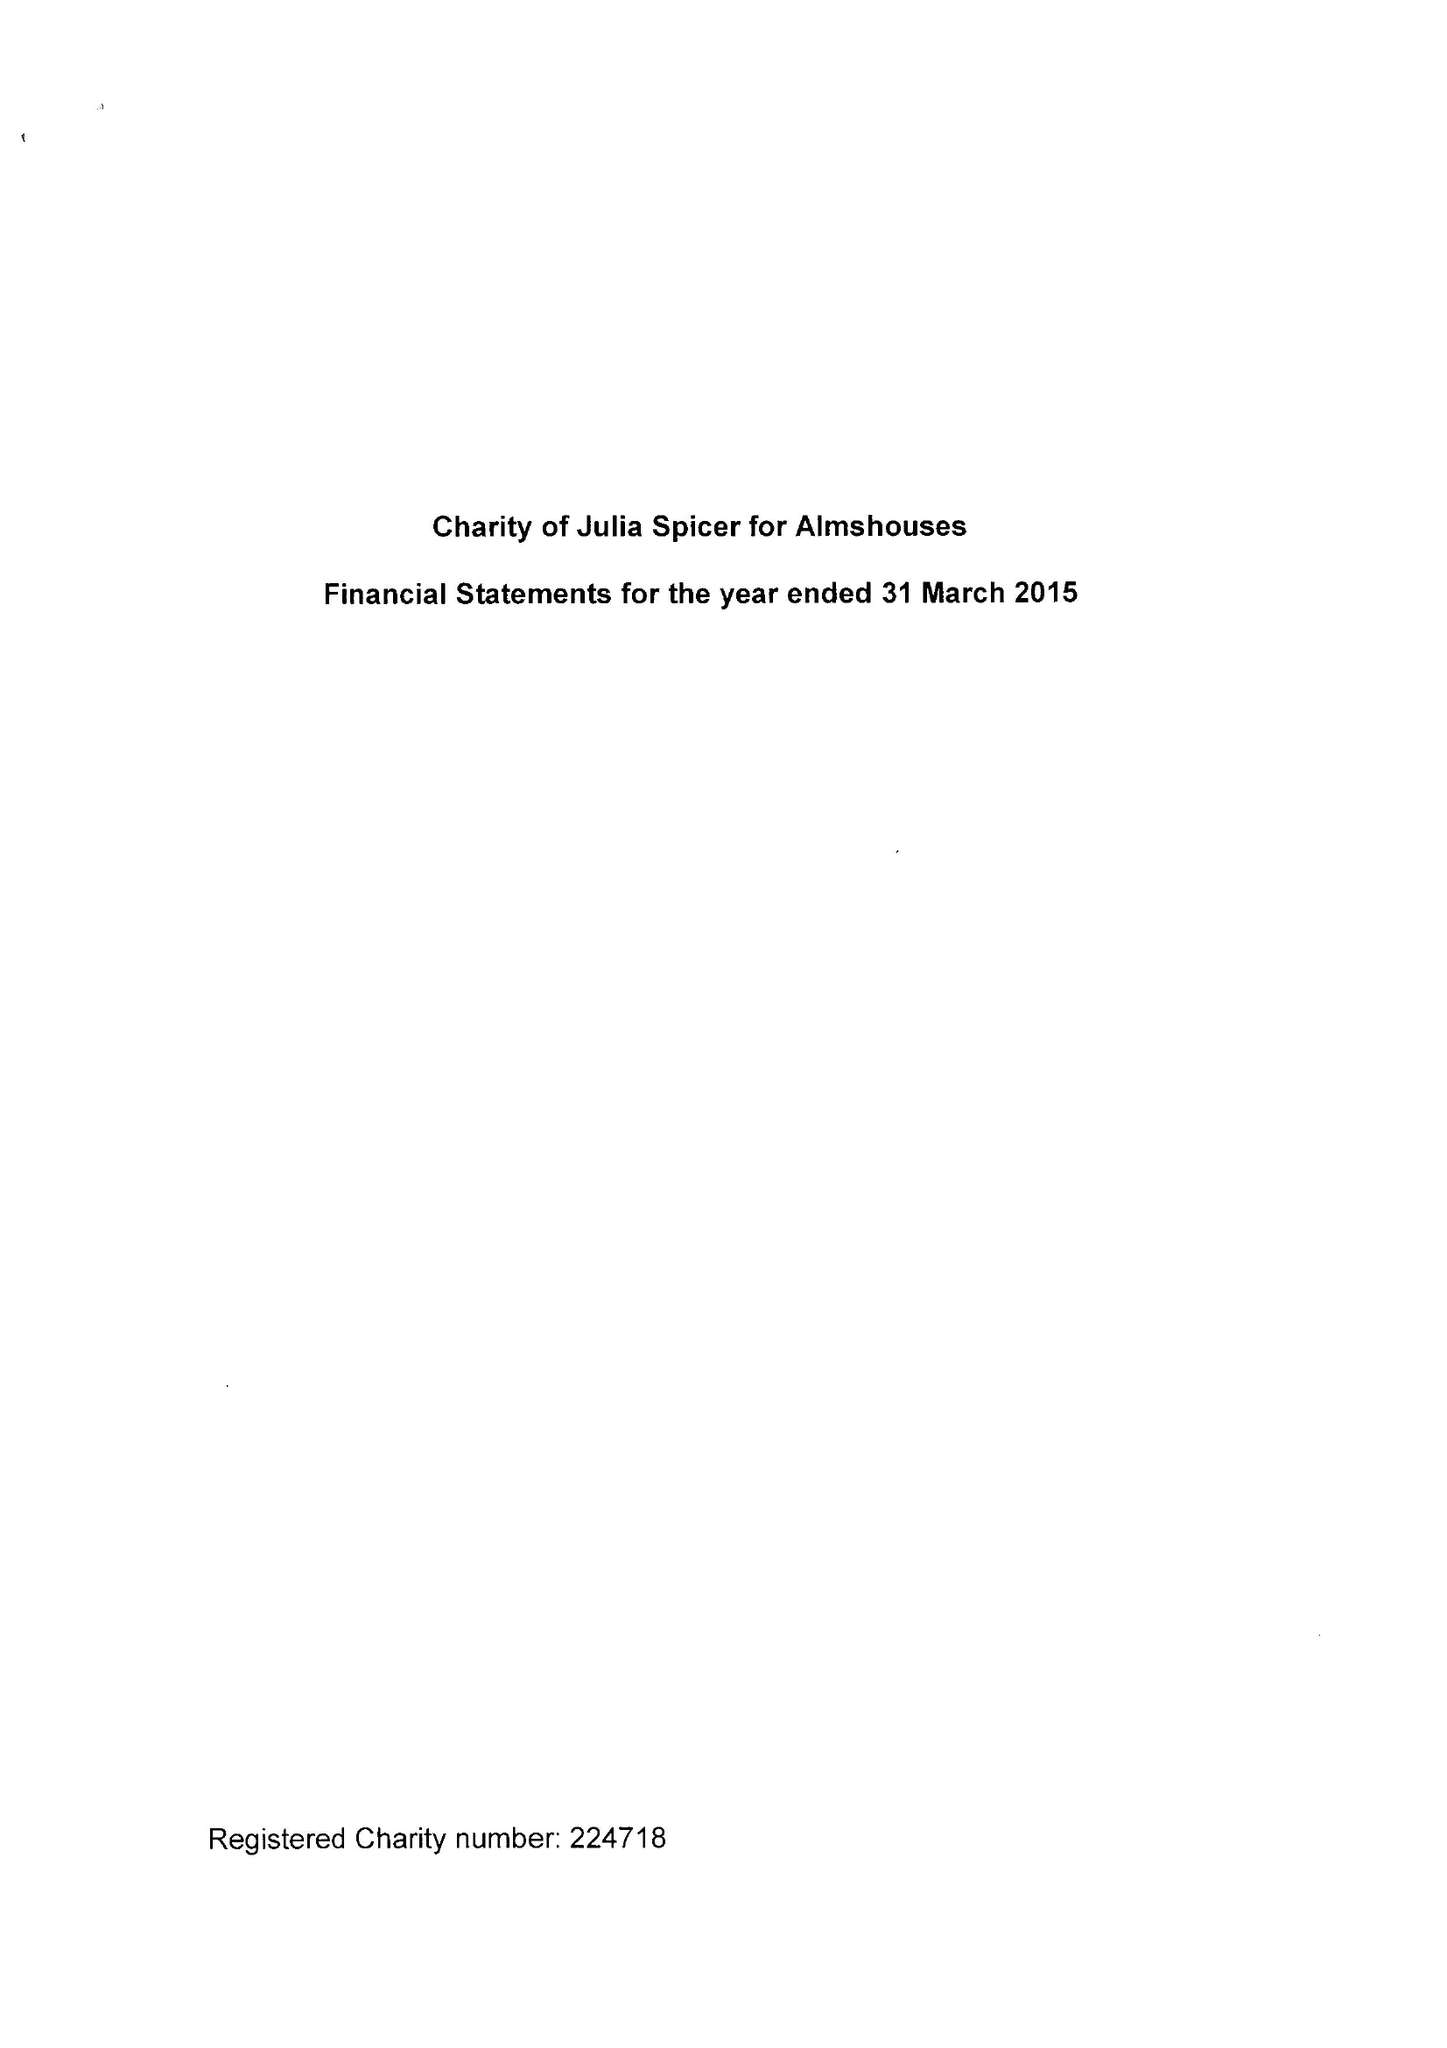What is the value for the charity_name?
Answer the question using a single word or phrase. Charity Of Julia Spicer For Almshouses 